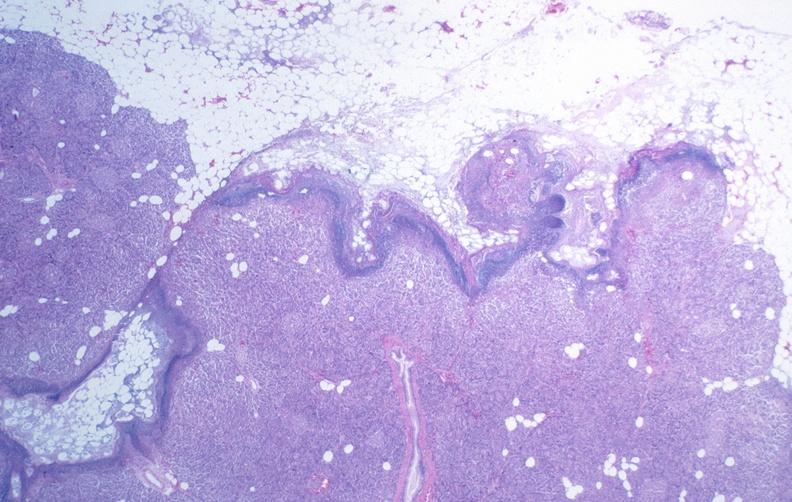does single metastatic appearing lesion show pancreatic fat necrosis?
Answer the question using a single word or phrase. No 